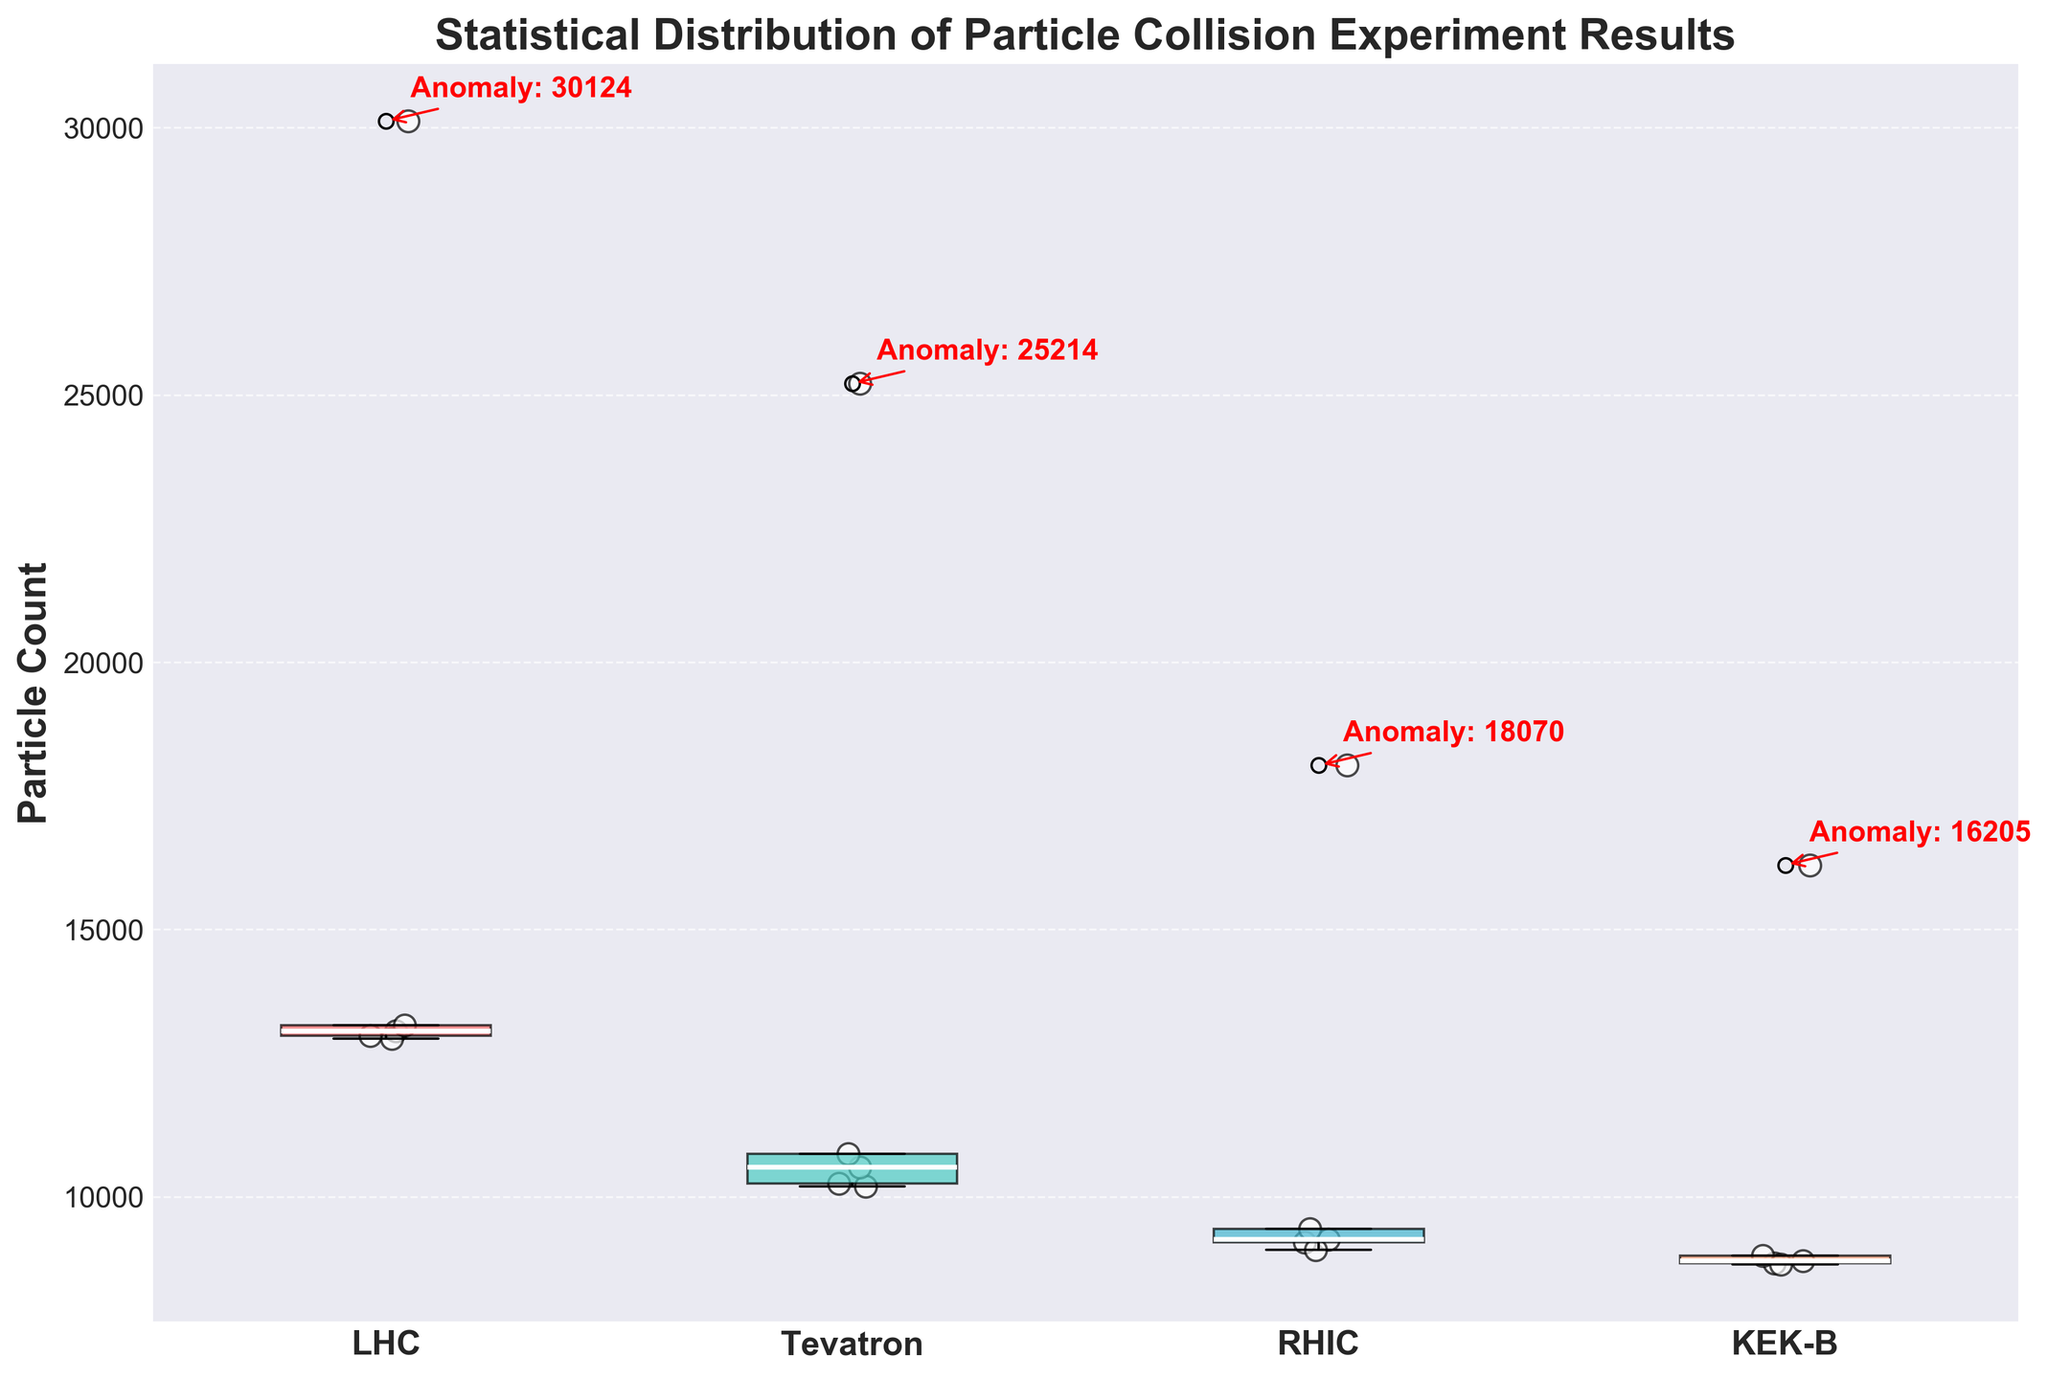How many particle colliders are represented in the figure? The x-axis labels indicate the names of the particle colliders, and there are four distinct labels.
Answer: Four Which particle collider shows the highest anomaly value in the data? Each anomaly value is annotated in red next to the respective scatter point. The LHC's anomaly at 30124 is the highest value.
Answer: LHC What is the median particle count value for experiments conducted in the Tevatron collider? The median is represented by the middle line in the box of the box plot for Tevatron.
Answer: 10545 Compare the general spread of particle counts between LHC and RHIC; which one appears more variable? The interquartile range (IQR) for LHC is much greater, and the box is larger and spans a wider range of values compared to RHIC.
Answer: LHC Are there any outliers indicated in the RHIC collider experiments? The scatter points outside the whiskers of the box plot for RHIC indicate outliers, and there's an anomaly annotation for 18070.
Answer: Yes What are the lower and upper quartiles of particle counts for experiments conducted at KEK-B? The lower quartile is at the bottom of the box (8750), and the upper quartile is at the top of the box (8900) for KEK-B.
Answer: 8750 and 8900 Compare the median particle count values between LHC and KEK-B; which one is higher? The median line in the box for LHC is positioned higher than the median line in the box for KEK-B.
Answer: LHC Identify which collider's box plot shows the smallest interquartile range (IQR). The box plot for KEK-B shows the smallest IQR, as the box is the narrowest.
Answer: KEK-B What is the approximate range of particle counts for regular experiments (excluding anomalies) in the LHC collider? By observing the bottom and top whiskers of the LHC's box plot (extend of the lines), the range is from approximately 12960 to 13210.
Answer: About 12960 to 13210 Based on the scatter points, which collider has the most compact grouping of particle counts? The Tevatron collider's scatter points are clustered very closely around the median and within a narrow range.
Answer: Tevatron 